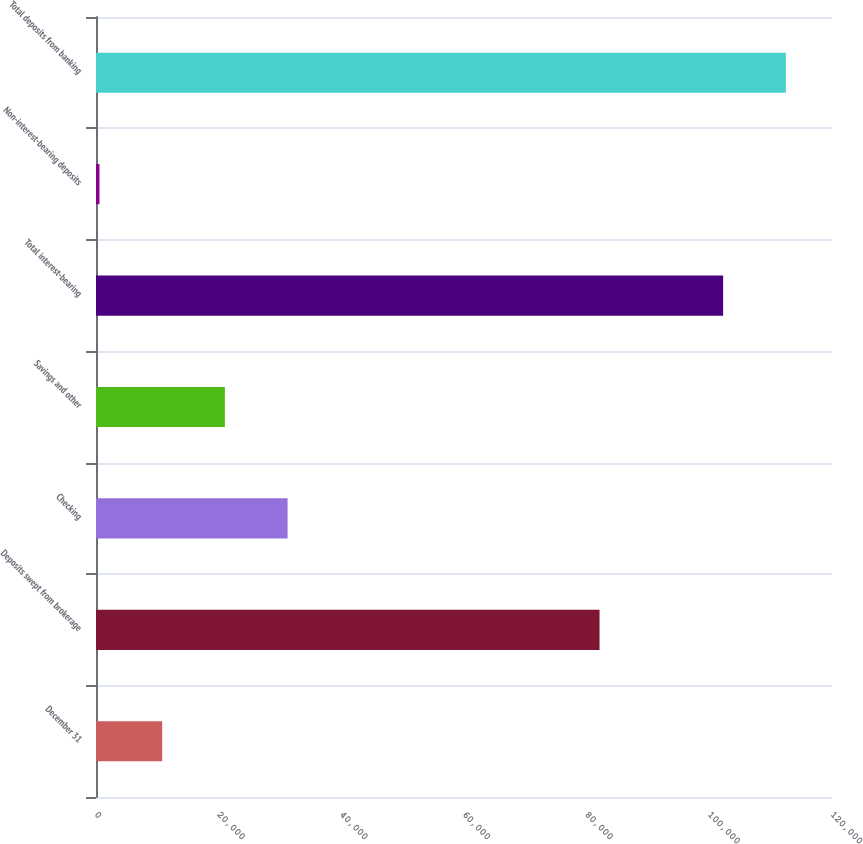Convert chart. <chart><loc_0><loc_0><loc_500><loc_500><bar_chart><fcel>December 31<fcel>Deposits swept from brokerage<fcel>Checking<fcel>Savings and other<fcel>Total interest-bearing<fcel>Non-interest-bearing deposits<fcel>Total deposits from banking<nl><fcel>10789.1<fcel>82101<fcel>31239.3<fcel>21014.2<fcel>102251<fcel>564<fcel>112476<nl></chart> 